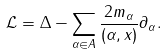Convert formula to latex. <formula><loc_0><loc_0><loc_500><loc_500>\mathcal { L } = \Delta - \sum _ { \alpha \in A } \frac { 2 m _ { \alpha } } { ( \alpha , x ) } \partial _ { \alpha } .</formula> 